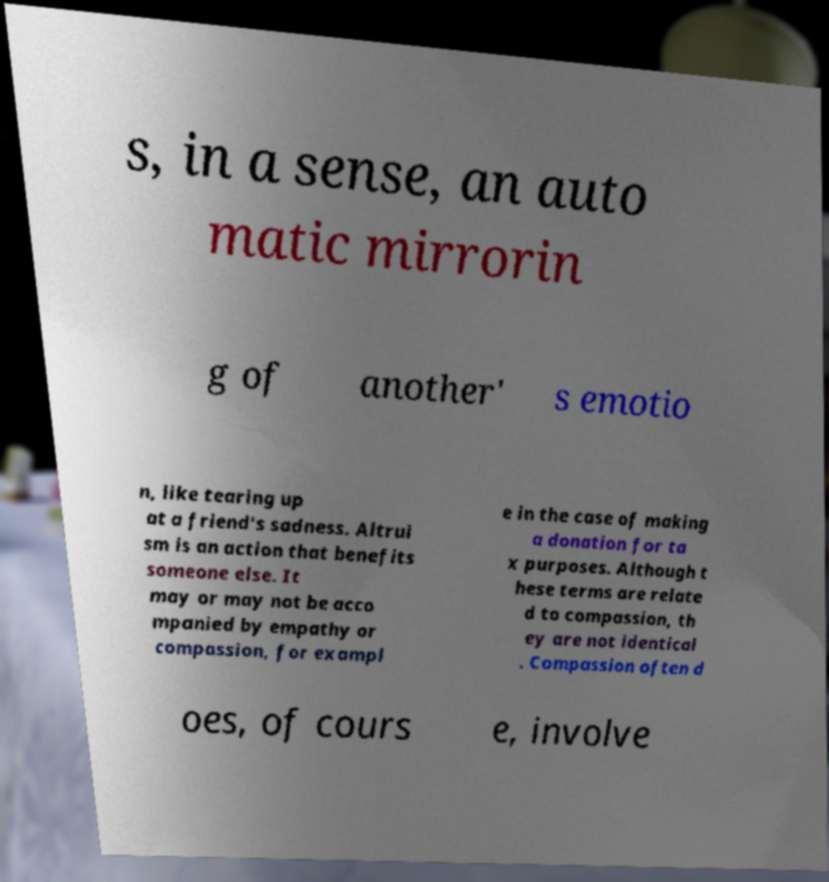Could you assist in decoding the text presented in this image and type it out clearly? s, in a sense, an auto matic mirrorin g of another' s emotio n, like tearing up at a friend's sadness. Altrui sm is an action that benefits someone else. It may or may not be acco mpanied by empathy or compassion, for exampl e in the case of making a donation for ta x purposes. Although t hese terms are relate d to compassion, th ey are not identical . Compassion often d oes, of cours e, involve 